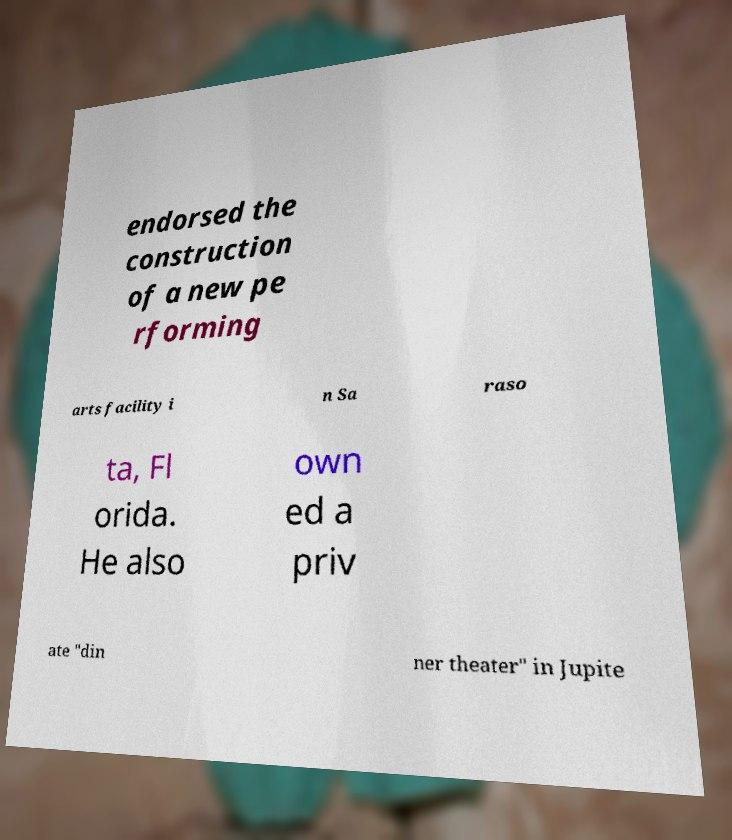For documentation purposes, I need the text within this image transcribed. Could you provide that? endorsed the construction of a new pe rforming arts facility i n Sa raso ta, Fl orida. He also own ed a priv ate "din ner theater" in Jupite 